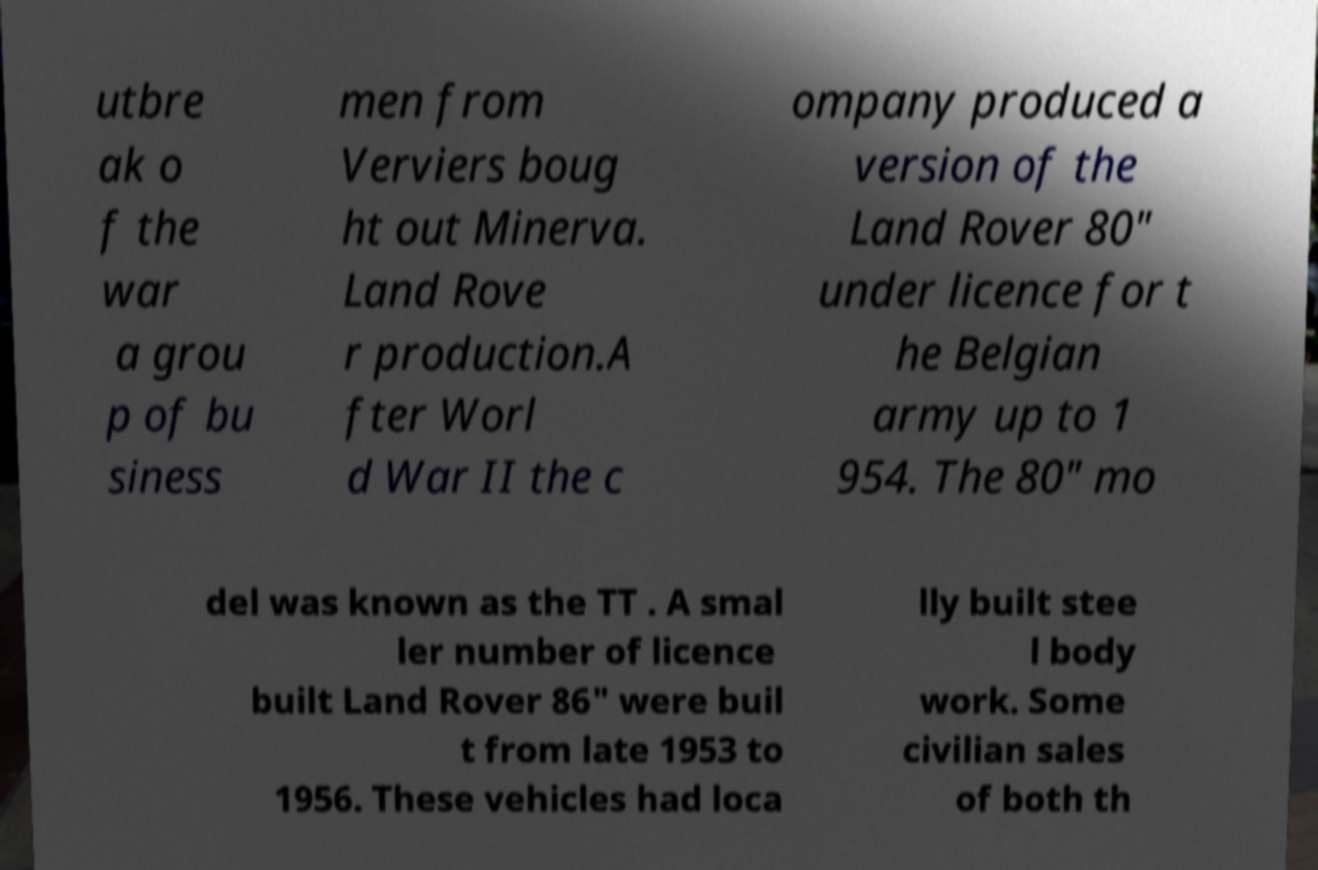What messages or text are displayed in this image? I need them in a readable, typed format. utbre ak o f the war a grou p of bu siness men from Verviers boug ht out Minerva. Land Rove r production.A fter Worl d War II the c ompany produced a version of the Land Rover 80" under licence for t he Belgian army up to 1 954. The 80" mo del was known as the TT . A smal ler number of licence built Land Rover 86" were buil t from late 1953 to 1956. These vehicles had loca lly built stee l body work. Some civilian sales of both th 